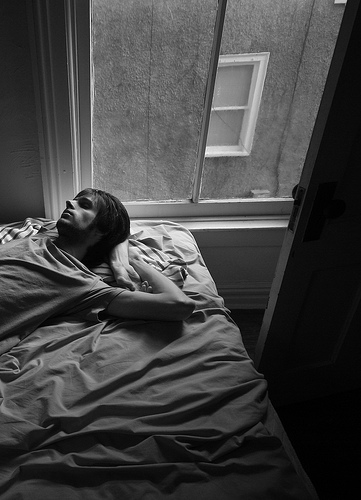What kind of furniture is the guy that is lying lying on? The guy is lying on a bed. 